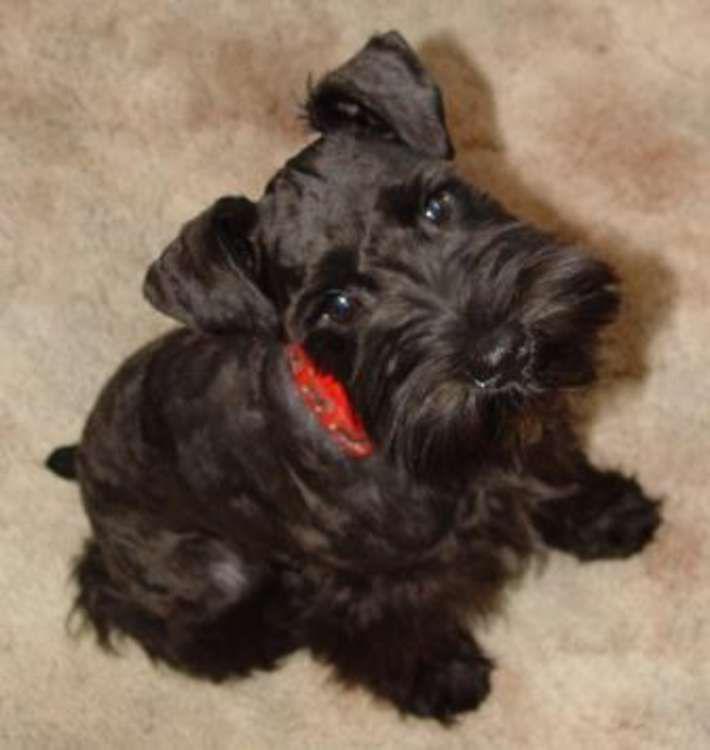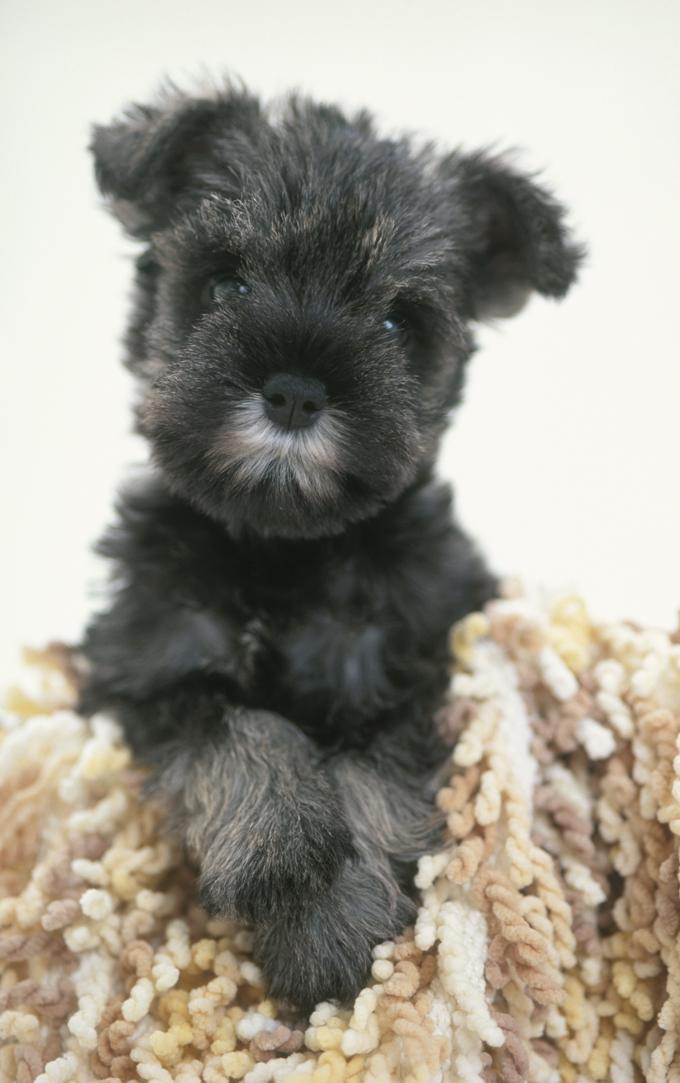The first image is the image on the left, the second image is the image on the right. Considering the images on both sides, is "At least one dog has his head tilted to the right." valid? Answer yes or no. Yes. The first image is the image on the left, the second image is the image on the right. Considering the images on both sides, is "An image shows a puppy with paws on something with stringy yarn-like fibers." valid? Answer yes or no. Yes. 